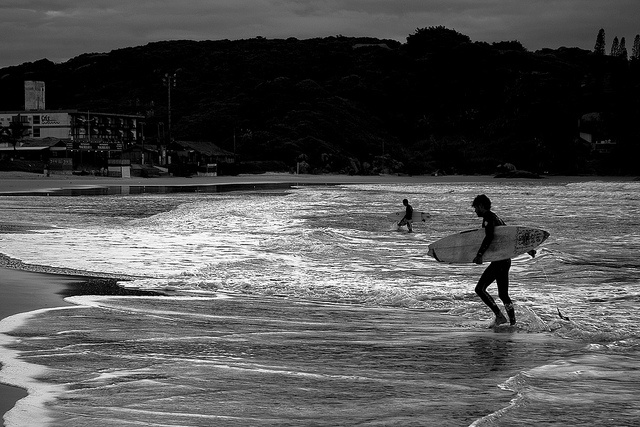Describe the objects in this image and their specific colors. I can see surfboard in black and gray tones, people in gray, black, darkgray, and lightgray tones, people in black and gray tones, people in gray, black, darkgray, and silver tones, and surfboard in black and gray tones in this image. 